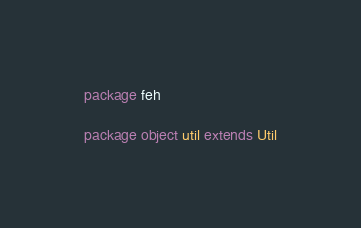<code> <loc_0><loc_0><loc_500><loc_500><_Scala_>package feh

package object util extends Util</code> 